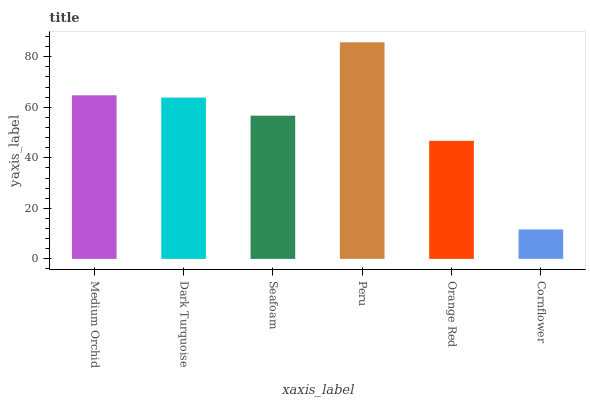Is Cornflower the minimum?
Answer yes or no. Yes. Is Peru the maximum?
Answer yes or no. Yes. Is Dark Turquoise the minimum?
Answer yes or no. No. Is Dark Turquoise the maximum?
Answer yes or no. No. Is Medium Orchid greater than Dark Turquoise?
Answer yes or no. Yes. Is Dark Turquoise less than Medium Orchid?
Answer yes or no. Yes. Is Dark Turquoise greater than Medium Orchid?
Answer yes or no. No. Is Medium Orchid less than Dark Turquoise?
Answer yes or no. No. Is Dark Turquoise the high median?
Answer yes or no. Yes. Is Seafoam the low median?
Answer yes or no. Yes. Is Medium Orchid the high median?
Answer yes or no. No. Is Medium Orchid the low median?
Answer yes or no. No. 